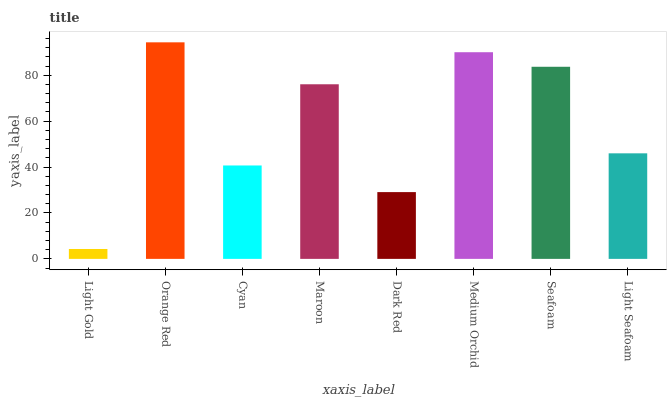Is Light Gold the minimum?
Answer yes or no. Yes. Is Orange Red the maximum?
Answer yes or no. Yes. Is Cyan the minimum?
Answer yes or no. No. Is Cyan the maximum?
Answer yes or no. No. Is Orange Red greater than Cyan?
Answer yes or no. Yes. Is Cyan less than Orange Red?
Answer yes or no. Yes. Is Cyan greater than Orange Red?
Answer yes or no. No. Is Orange Red less than Cyan?
Answer yes or no. No. Is Maroon the high median?
Answer yes or no. Yes. Is Light Seafoam the low median?
Answer yes or no. Yes. Is Medium Orchid the high median?
Answer yes or no. No. Is Orange Red the low median?
Answer yes or no. No. 